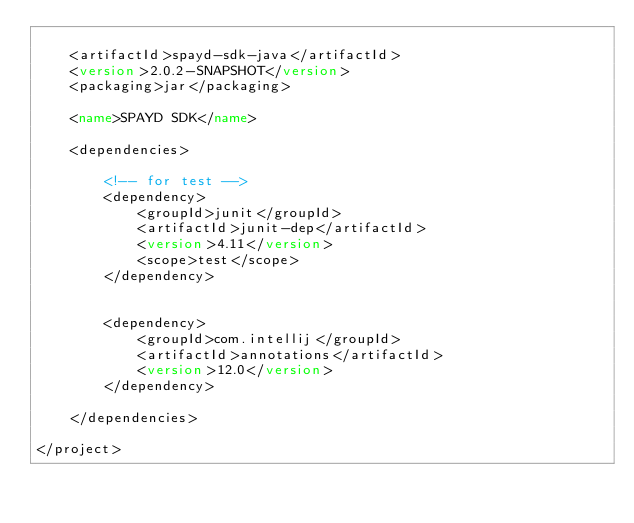<code> <loc_0><loc_0><loc_500><loc_500><_XML_>
	<artifactId>spayd-sdk-java</artifactId>
	<version>2.0.2-SNAPSHOT</version>
	<packaging>jar</packaging>

	<name>SPAYD SDK</name>

	<dependencies>

		<!-- for test -->
		<dependency>
			<groupId>junit</groupId>
			<artifactId>junit-dep</artifactId>
			<version>4.11</version>
			<scope>test</scope>
		</dependency>


		<dependency>
			<groupId>com.intellij</groupId>
			<artifactId>annotations</artifactId>
			<version>12.0</version>
		</dependency>

	</dependencies>

</project>
</code> 